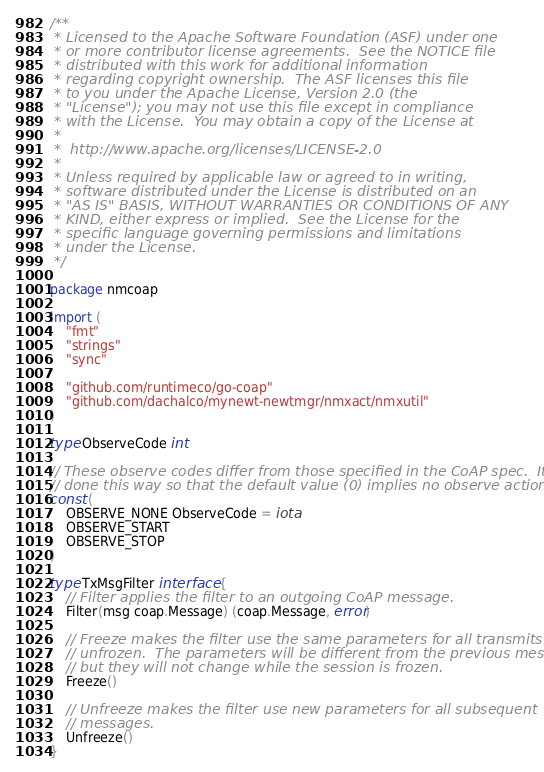<code> <loc_0><loc_0><loc_500><loc_500><_Go_>/**
 * Licensed to the Apache Software Foundation (ASF) under one
 * or more contributor license agreements.  See the NOTICE file
 * distributed with this work for additional information
 * regarding copyright ownership.  The ASF licenses this file
 * to you under the Apache License, Version 2.0 (the
 * "License"); you may not use this file except in compliance
 * with the License.  You may obtain a copy of the License at
 *
 *  http://www.apache.org/licenses/LICENSE-2.0
 *
 * Unless required by applicable law or agreed to in writing,
 * software distributed under the License is distributed on an
 * "AS IS" BASIS, WITHOUT WARRANTIES OR CONDITIONS OF ANY
 * KIND, either express or implied.  See the License for the
 * specific language governing permissions and limitations
 * under the License.
 */

package nmcoap

import (
	"fmt"
	"strings"
	"sync"

	"github.com/runtimeco/go-coap"
	"github.com/dachalco/mynewt-newtmgr/nmxact/nmxutil"
)

type ObserveCode int

// These observe codes differ from those specified in the CoAP spec.  It is
// done this way so that the default value (0) implies no observe action.
const (
	OBSERVE_NONE ObserveCode = iota
	OBSERVE_START
	OBSERVE_STOP
)

type TxMsgFilter interface {
	// Filter applies the filter to an outgoing CoAP message.
	Filter(msg coap.Message) (coap.Message, error)

	// Freeze makes the filter use the same parameters for all transmits until
	// unfrozen.  The parameters will be different from the previous message,
	// but they will not change while the session is frozen.
	Freeze()

	// Unfreeze makes the filter use new parameters for all subsequent
	// messages.
	Unfreeze()
}
</code> 